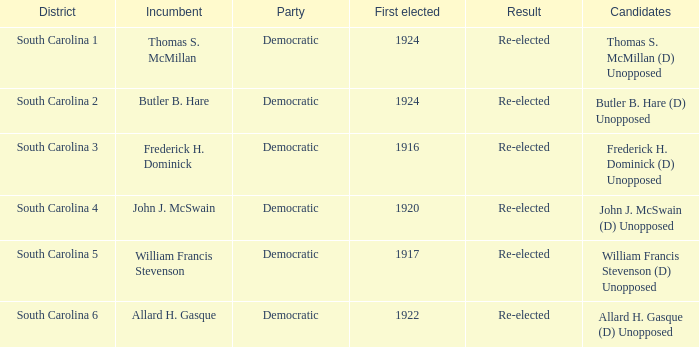Which individual is the contender in south carolina's district 2? Butler B. Hare (D) Unopposed. 